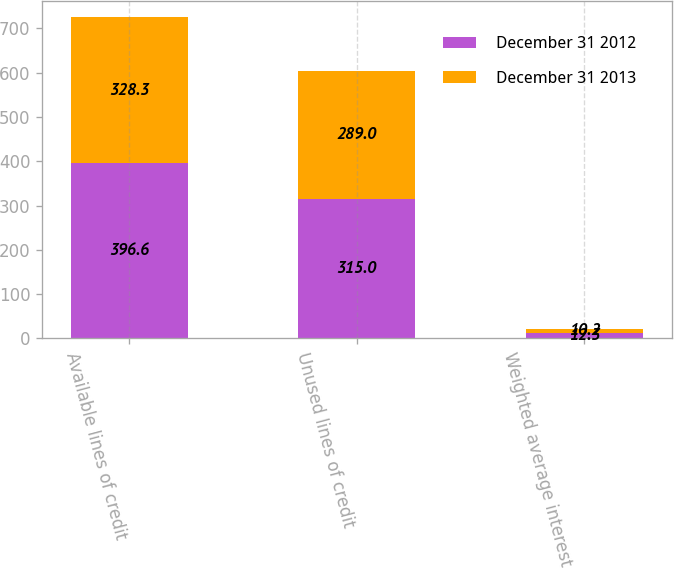Convert chart to OTSL. <chart><loc_0><loc_0><loc_500><loc_500><stacked_bar_chart><ecel><fcel>Available lines of credit<fcel>Unused lines of credit<fcel>Weighted average interest rate<nl><fcel>December 31 2012<fcel>396.6<fcel>315<fcel>12.3<nl><fcel>December 31 2013<fcel>328.3<fcel>289<fcel>10.2<nl></chart> 